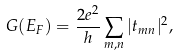<formula> <loc_0><loc_0><loc_500><loc_500>G ( E _ { F } ) = \frac { 2 e ^ { 2 } } { h } \sum _ { m , n } | t _ { m n } | ^ { 2 } ,</formula> 